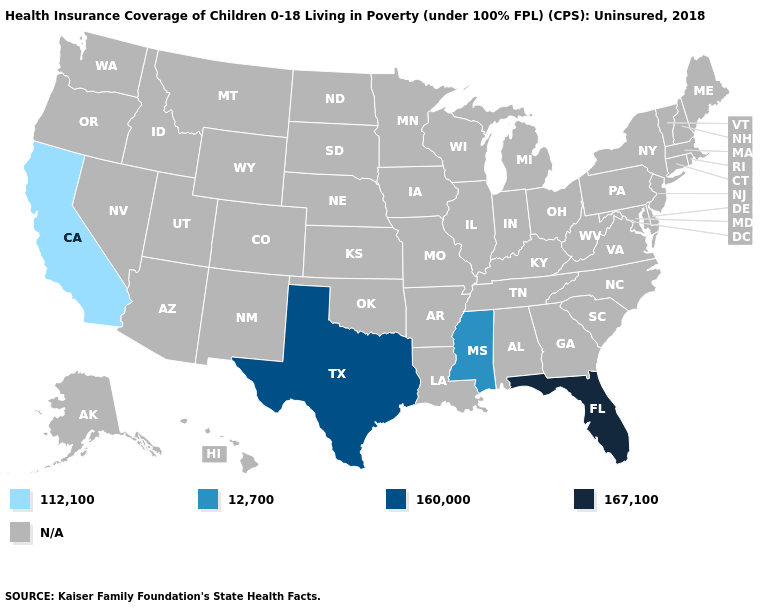Does California have the lowest value in the USA?
Short answer required. Yes. Does Texas have the lowest value in the South?
Be succinct. No. What is the highest value in the South ?
Quick response, please. 167,100. Does California have the lowest value in the USA?
Concise answer only. Yes. What is the value of Missouri?
Short answer required. N/A. Name the states that have a value in the range 112,100?
Keep it brief. California. Does California have the lowest value in the USA?
Short answer required. Yes. Name the states that have a value in the range 167,100?
Be succinct. Florida. Does the first symbol in the legend represent the smallest category?
Write a very short answer. Yes. Among the states that border New Mexico , which have the lowest value?
Quick response, please. Texas. 